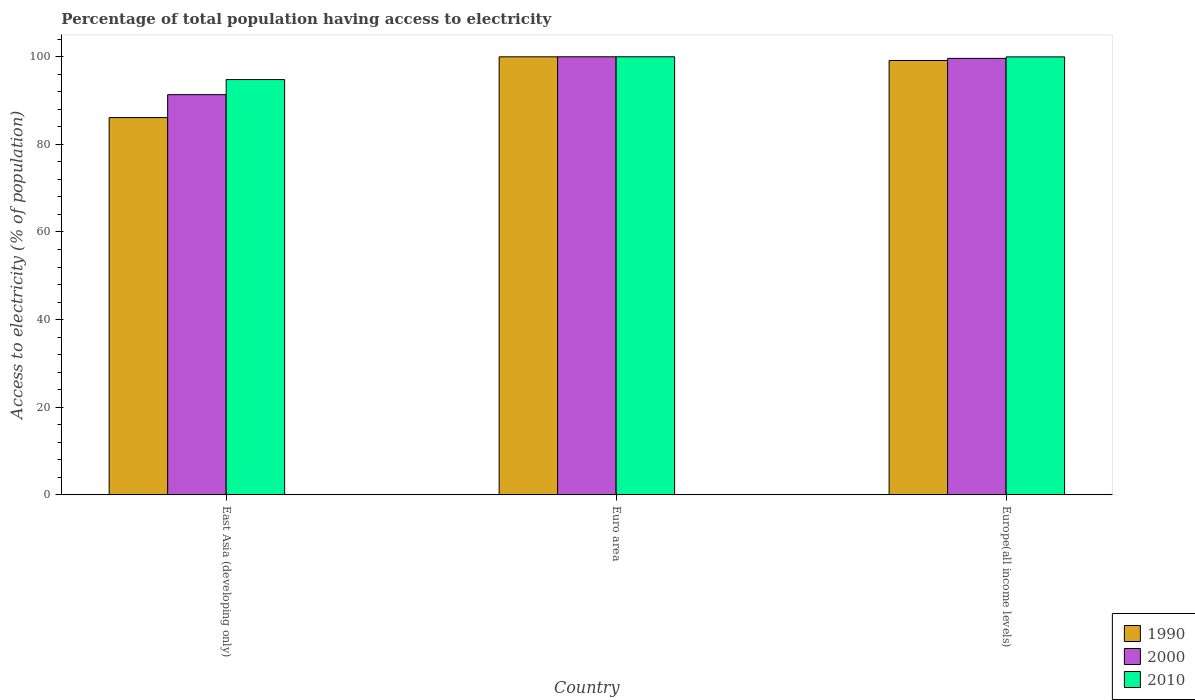Are the number of bars per tick equal to the number of legend labels?
Your answer should be very brief. Yes. What is the label of the 1st group of bars from the left?
Your answer should be very brief. East Asia (developing only). In how many cases, is the number of bars for a given country not equal to the number of legend labels?
Ensure brevity in your answer.  0. What is the percentage of population that have access to electricity in 2010 in East Asia (developing only)?
Offer a very short reply. 94.8. Across all countries, what is the minimum percentage of population that have access to electricity in 2010?
Make the answer very short. 94.8. In which country was the percentage of population that have access to electricity in 2000 minimum?
Offer a very short reply. East Asia (developing only). What is the total percentage of population that have access to electricity in 1990 in the graph?
Provide a succinct answer. 285.26. What is the difference between the percentage of population that have access to electricity in 2010 in East Asia (developing only) and that in Euro area?
Your answer should be compact. -5.2. What is the difference between the percentage of population that have access to electricity in 1990 in Europe(all income levels) and the percentage of population that have access to electricity in 2010 in Euro area?
Provide a succinct answer. -0.85. What is the average percentage of population that have access to electricity in 2000 per country?
Keep it short and to the point. 96.99. What is the difference between the percentage of population that have access to electricity of/in 2000 and percentage of population that have access to electricity of/in 2010 in East Asia (developing only)?
Keep it short and to the point. -3.45. In how many countries, is the percentage of population that have access to electricity in 2000 greater than 80 %?
Make the answer very short. 3. What is the ratio of the percentage of population that have access to electricity in 2010 in Euro area to that in Europe(all income levels)?
Your answer should be very brief. 1. Is the percentage of population that have access to electricity in 1990 in Euro area less than that in Europe(all income levels)?
Keep it short and to the point. No. Is the difference between the percentage of population that have access to electricity in 2000 in East Asia (developing only) and Euro area greater than the difference between the percentage of population that have access to electricity in 2010 in East Asia (developing only) and Euro area?
Offer a very short reply. No. What is the difference between the highest and the second highest percentage of population that have access to electricity in 2000?
Give a very brief answer. -8.28. What is the difference between the highest and the lowest percentage of population that have access to electricity in 2010?
Provide a succinct answer. 5.2. In how many countries, is the percentage of population that have access to electricity in 2010 greater than the average percentage of population that have access to electricity in 2010 taken over all countries?
Offer a terse response. 2. What does the 3rd bar from the right in Europe(all income levels) represents?
Your response must be concise. 1990. Is it the case that in every country, the sum of the percentage of population that have access to electricity in 2010 and percentage of population that have access to electricity in 2000 is greater than the percentage of population that have access to electricity in 1990?
Your answer should be very brief. Yes. How many bars are there?
Give a very brief answer. 9. Does the graph contain grids?
Provide a short and direct response. No. Where does the legend appear in the graph?
Offer a terse response. Bottom right. How many legend labels are there?
Make the answer very short. 3. How are the legend labels stacked?
Make the answer very short. Vertical. What is the title of the graph?
Provide a succinct answer. Percentage of total population having access to electricity. Does "2007" appear as one of the legend labels in the graph?
Your response must be concise. No. What is the label or title of the Y-axis?
Ensure brevity in your answer.  Access to electricity (% of population). What is the Access to electricity (% of population) in 1990 in East Asia (developing only)?
Offer a very short reply. 86.12. What is the Access to electricity (% of population) in 2000 in East Asia (developing only)?
Provide a short and direct response. 91.35. What is the Access to electricity (% of population) in 2010 in East Asia (developing only)?
Give a very brief answer. 94.8. What is the Access to electricity (% of population) in 1990 in Euro area?
Ensure brevity in your answer.  99.99. What is the Access to electricity (% of population) of 1990 in Europe(all income levels)?
Keep it short and to the point. 99.15. What is the Access to electricity (% of population) of 2000 in Europe(all income levels)?
Offer a very short reply. 99.63. What is the Access to electricity (% of population) of 2010 in Europe(all income levels)?
Make the answer very short. 99.97. Across all countries, what is the maximum Access to electricity (% of population) in 1990?
Keep it short and to the point. 99.99. Across all countries, what is the maximum Access to electricity (% of population) of 2010?
Keep it short and to the point. 100. Across all countries, what is the minimum Access to electricity (% of population) in 1990?
Ensure brevity in your answer.  86.12. Across all countries, what is the minimum Access to electricity (% of population) in 2000?
Give a very brief answer. 91.35. Across all countries, what is the minimum Access to electricity (% of population) in 2010?
Provide a short and direct response. 94.8. What is the total Access to electricity (% of population) of 1990 in the graph?
Make the answer very short. 285.26. What is the total Access to electricity (% of population) of 2000 in the graph?
Give a very brief answer. 290.98. What is the total Access to electricity (% of population) of 2010 in the graph?
Offer a terse response. 294.77. What is the difference between the Access to electricity (% of population) in 1990 in East Asia (developing only) and that in Euro area?
Make the answer very short. -13.87. What is the difference between the Access to electricity (% of population) in 2000 in East Asia (developing only) and that in Euro area?
Offer a terse response. -8.65. What is the difference between the Access to electricity (% of population) in 1990 in East Asia (developing only) and that in Europe(all income levels)?
Your response must be concise. -13.03. What is the difference between the Access to electricity (% of population) in 2000 in East Asia (developing only) and that in Europe(all income levels)?
Ensure brevity in your answer.  -8.28. What is the difference between the Access to electricity (% of population) in 2010 in East Asia (developing only) and that in Europe(all income levels)?
Ensure brevity in your answer.  -5.17. What is the difference between the Access to electricity (% of population) in 1990 in Euro area and that in Europe(all income levels)?
Offer a very short reply. 0.84. What is the difference between the Access to electricity (% of population) in 2000 in Euro area and that in Europe(all income levels)?
Give a very brief answer. 0.37. What is the difference between the Access to electricity (% of population) in 2010 in Euro area and that in Europe(all income levels)?
Offer a very short reply. 0.03. What is the difference between the Access to electricity (% of population) of 1990 in East Asia (developing only) and the Access to electricity (% of population) of 2000 in Euro area?
Provide a short and direct response. -13.88. What is the difference between the Access to electricity (% of population) of 1990 in East Asia (developing only) and the Access to electricity (% of population) of 2010 in Euro area?
Your response must be concise. -13.88. What is the difference between the Access to electricity (% of population) in 2000 in East Asia (developing only) and the Access to electricity (% of population) in 2010 in Euro area?
Your answer should be compact. -8.65. What is the difference between the Access to electricity (% of population) in 1990 in East Asia (developing only) and the Access to electricity (% of population) in 2000 in Europe(all income levels)?
Provide a short and direct response. -13.51. What is the difference between the Access to electricity (% of population) in 1990 in East Asia (developing only) and the Access to electricity (% of population) in 2010 in Europe(all income levels)?
Keep it short and to the point. -13.86. What is the difference between the Access to electricity (% of population) of 2000 in East Asia (developing only) and the Access to electricity (% of population) of 2010 in Europe(all income levels)?
Offer a very short reply. -8.63. What is the difference between the Access to electricity (% of population) of 1990 in Euro area and the Access to electricity (% of population) of 2000 in Europe(all income levels)?
Keep it short and to the point. 0.36. What is the difference between the Access to electricity (% of population) of 1990 in Euro area and the Access to electricity (% of population) of 2010 in Europe(all income levels)?
Provide a succinct answer. 0.02. What is the difference between the Access to electricity (% of population) of 2000 in Euro area and the Access to electricity (% of population) of 2010 in Europe(all income levels)?
Provide a short and direct response. 0.03. What is the average Access to electricity (% of population) in 1990 per country?
Make the answer very short. 95.09. What is the average Access to electricity (% of population) in 2000 per country?
Make the answer very short. 96.99. What is the average Access to electricity (% of population) of 2010 per country?
Your answer should be very brief. 98.26. What is the difference between the Access to electricity (% of population) of 1990 and Access to electricity (% of population) of 2000 in East Asia (developing only)?
Your response must be concise. -5.23. What is the difference between the Access to electricity (% of population) of 1990 and Access to electricity (% of population) of 2010 in East Asia (developing only)?
Give a very brief answer. -8.68. What is the difference between the Access to electricity (% of population) of 2000 and Access to electricity (% of population) of 2010 in East Asia (developing only)?
Your response must be concise. -3.45. What is the difference between the Access to electricity (% of population) of 1990 and Access to electricity (% of population) of 2000 in Euro area?
Make the answer very short. -0.01. What is the difference between the Access to electricity (% of population) of 1990 and Access to electricity (% of population) of 2010 in Euro area?
Your answer should be very brief. -0.01. What is the difference between the Access to electricity (% of population) in 1990 and Access to electricity (% of population) in 2000 in Europe(all income levels)?
Keep it short and to the point. -0.48. What is the difference between the Access to electricity (% of population) of 1990 and Access to electricity (% of population) of 2010 in Europe(all income levels)?
Your response must be concise. -0.82. What is the difference between the Access to electricity (% of population) in 2000 and Access to electricity (% of population) in 2010 in Europe(all income levels)?
Provide a short and direct response. -0.34. What is the ratio of the Access to electricity (% of population) in 1990 in East Asia (developing only) to that in Euro area?
Offer a very short reply. 0.86. What is the ratio of the Access to electricity (% of population) in 2000 in East Asia (developing only) to that in Euro area?
Provide a succinct answer. 0.91. What is the ratio of the Access to electricity (% of population) in 2010 in East Asia (developing only) to that in Euro area?
Offer a terse response. 0.95. What is the ratio of the Access to electricity (% of population) of 1990 in East Asia (developing only) to that in Europe(all income levels)?
Your response must be concise. 0.87. What is the ratio of the Access to electricity (% of population) of 2000 in East Asia (developing only) to that in Europe(all income levels)?
Provide a succinct answer. 0.92. What is the ratio of the Access to electricity (% of population) of 2010 in East Asia (developing only) to that in Europe(all income levels)?
Make the answer very short. 0.95. What is the ratio of the Access to electricity (% of population) in 1990 in Euro area to that in Europe(all income levels)?
Give a very brief answer. 1.01. What is the ratio of the Access to electricity (% of population) of 2010 in Euro area to that in Europe(all income levels)?
Give a very brief answer. 1. What is the difference between the highest and the second highest Access to electricity (% of population) in 1990?
Ensure brevity in your answer.  0.84. What is the difference between the highest and the second highest Access to electricity (% of population) in 2000?
Provide a short and direct response. 0.37. What is the difference between the highest and the second highest Access to electricity (% of population) of 2010?
Offer a very short reply. 0.03. What is the difference between the highest and the lowest Access to electricity (% of population) of 1990?
Your answer should be very brief. 13.87. What is the difference between the highest and the lowest Access to electricity (% of population) in 2000?
Make the answer very short. 8.65. 